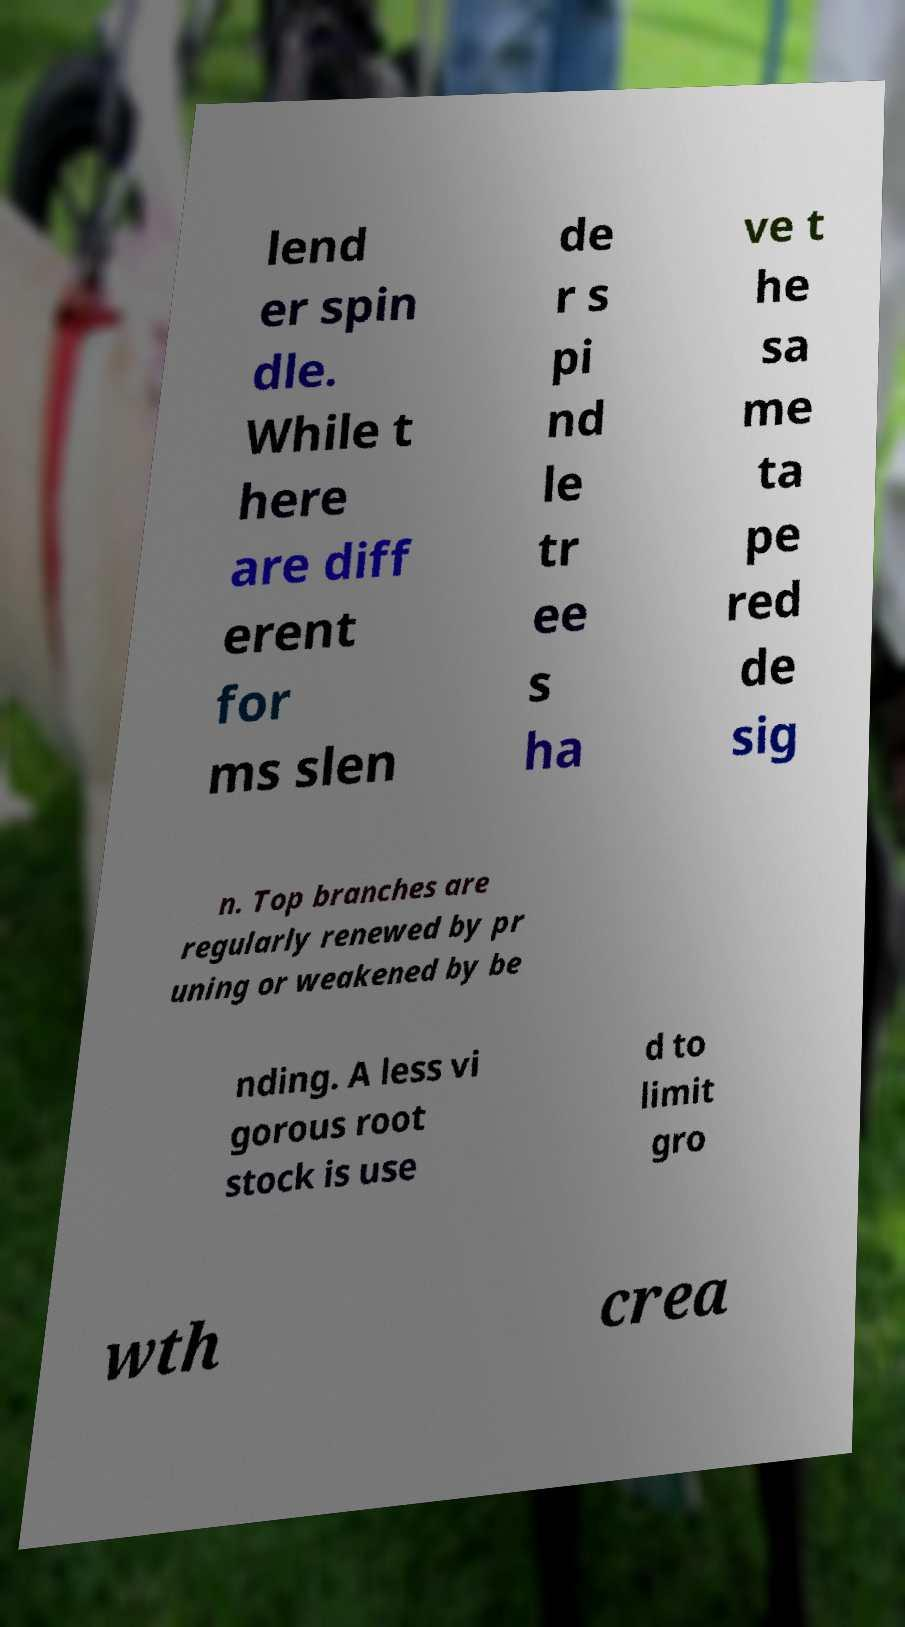What messages or text are displayed in this image? I need them in a readable, typed format. lend er spin dle. While t here are diff erent for ms slen de r s pi nd le tr ee s ha ve t he sa me ta pe red de sig n. Top branches are regularly renewed by pr uning or weakened by be nding. A less vi gorous root stock is use d to limit gro wth crea 